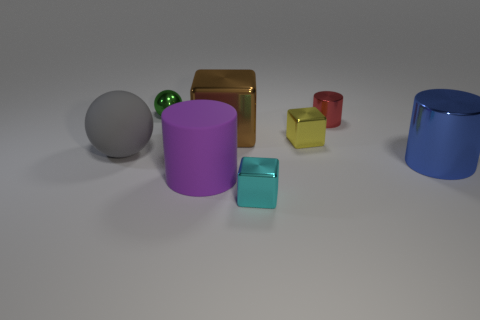Add 1 small cyan metal objects. How many objects exist? 9 Subtract all spheres. How many objects are left? 6 Add 2 large blue metallic things. How many large blue metallic things exist? 3 Subtract 0 blue cubes. How many objects are left? 8 Subtract all small green rubber balls. Subtract all small metallic balls. How many objects are left? 7 Add 4 blue metal objects. How many blue metal objects are left? 5 